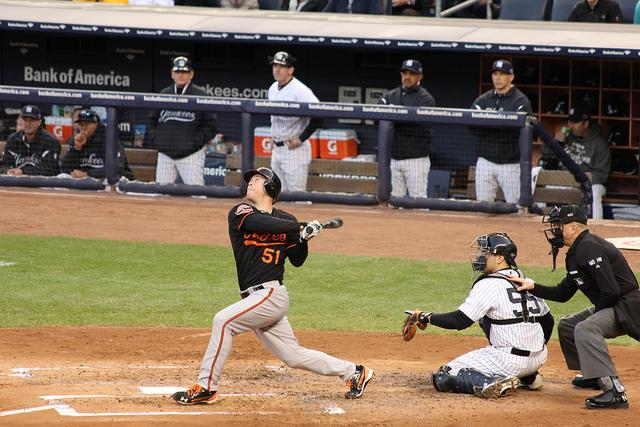What holds the beverages for the players in the dugout? coolers 